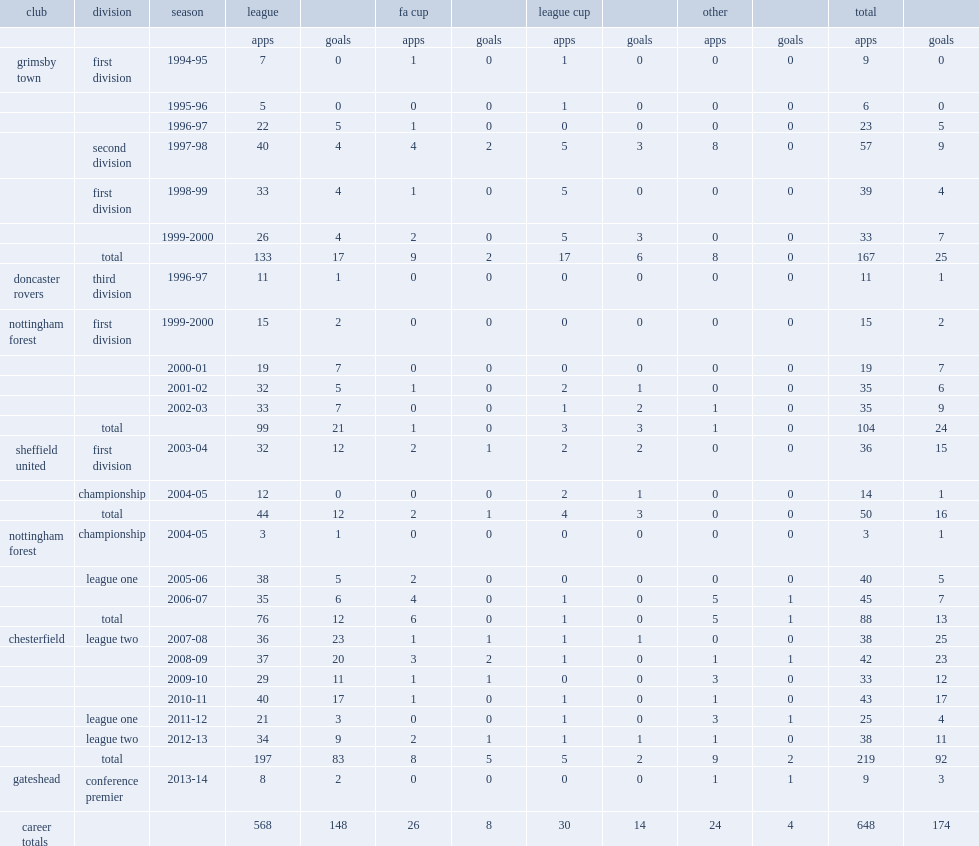What was the number of league appearances made by jack lester in grimsby town? 133.0. 